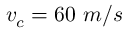Convert formula to latex. <formula><loc_0><loc_0><loc_500><loc_500>v _ { c } = 6 0 m / s</formula> 